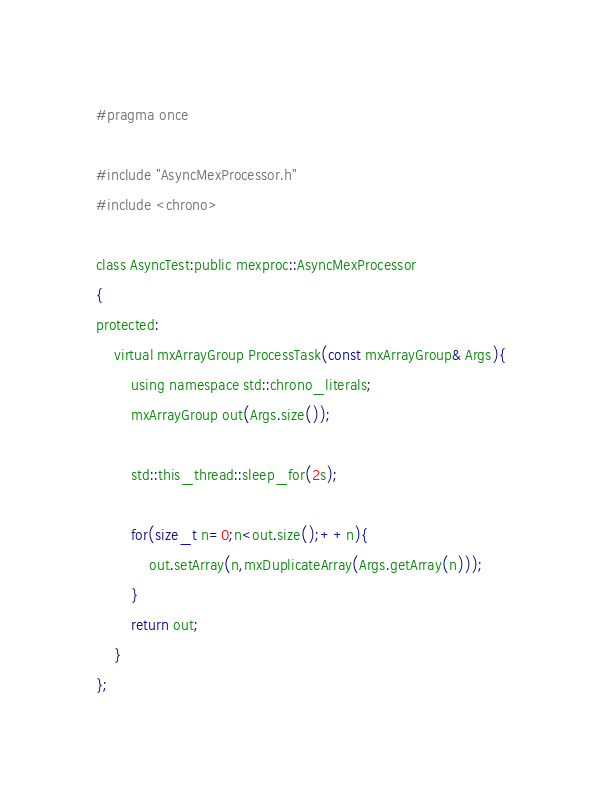<code> <loc_0><loc_0><loc_500><loc_500><_C_>#pragma once

#include "AsyncMexProcessor.h"
#include <chrono>

class AsyncTest:public mexproc::AsyncMexProcessor
{
protected:
    virtual mxArrayGroup ProcessTask(const mxArrayGroup& Args){
        using namespace std::chrono_literals;
        mxArrayGroup out(Args.size());

        std::this_thread::sleep_for(2s);

        for(size_t n=0;n<out.size();++n){
            out.setArray(n,mxDuplicateArray(Args.getArray(n)));
        }
        return out;
    }
};
</code> 